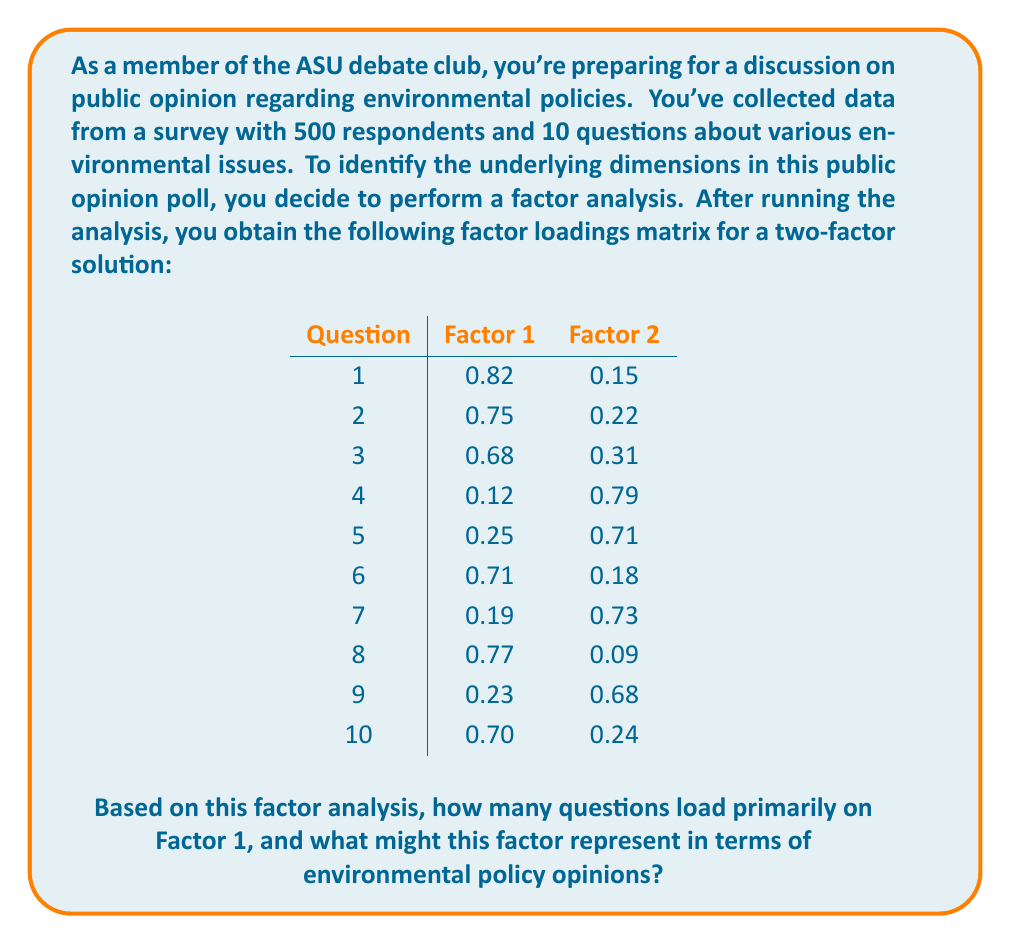Teach me how to tackle this problem. To answer this question, we need to follow these steps:

1. Understand factor loadings:
   Factor loadings represent the correlation between each variable (question) and the underlying factor. Generally, loadings above 0.5 or 0.6 are considered significant.

2. Identify primary loadings:
   We'll consider a question to load primarily on a factor if its loading for that factor is greater than 0.5 and substantially higher than its loading on the other factor.

3. Count questions loading on Factor 1:
   Let's go through each question:
   - Question 1: 0.82 on Factor 1, 0.15 on Factor 2 → Factor 1
   - Question 2: 0.75 on Factor 1, 0.22 on Factor 2 → Factor 1
   - Question 3: 0.68 on Factor 1, 0.31 on Factor 2 → Factor 1
   - Question 4: 0.12 on Factor 1, 0.79 on Factor 2 → Factor 2
   - Question 5: 0.25 on Factor 1, 0.71 on Factor 2 → Factor 2
   - Question 6: 0.71 on Factor 1, 0.18 on Factor 2 → Factor 1
   - Question 7: 0.19 on Factor 1, 0.73 on Factor 2 → Factor 2
   - Question 8: 0.77 on Factor 1, 0.09 on Factor 2 → Factor 1
   - Question 9: 0.23 on Factor 1, 0.68 on Factor 2 → Factor 2
   - Question 10: 0.70 on Factor 1, 0.24 on Factor 2 → Factor 1

   In total, 6 questions (1, 2, 3, 6, 8, and 10) load primarily on Factor 1.

4. Interpret Factor 1:
   To interpret what Factor 1 might represent, we need to consider the common theme among the questions that load highly on this factor. In the context of environmental policy opinions, Factor 1 could represent general attitudes towards environmental protection or support for long-term sustainability measures. This interpretation is based on the fact that it captures the majority of the questions and likely represents a broader, overarching dimension of environmental concern.
Answer: 6 questions load primarily on Factor 1. This factor likely represents general attitudes towards environmental protection or support for long-term sustainability measures in environmental policy opinions. 